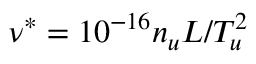<formula> <loc_0><loc_0><loc_500><loc_500>\nu ^ { * } = 1 0 ^ { - 1 6 } n _ { u } L / T _ { u } ^ { 2 }</formula> 